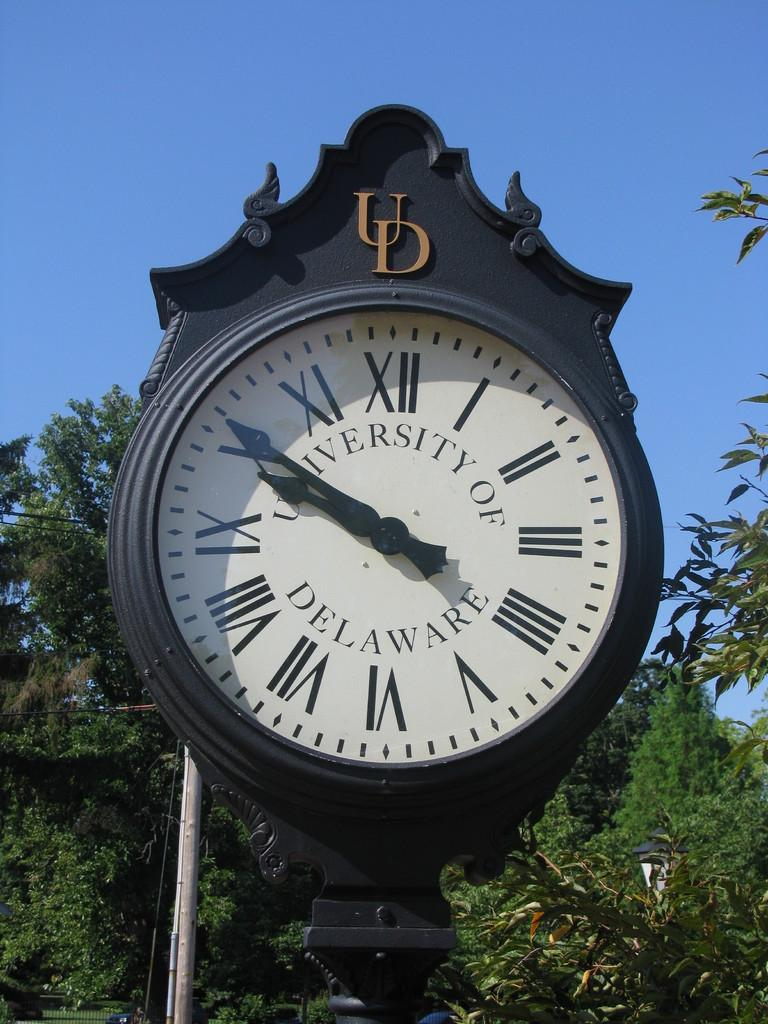<image>
Offer a succinct explanation of the picture presented. Circule clock that says University of Delaware on the face. 